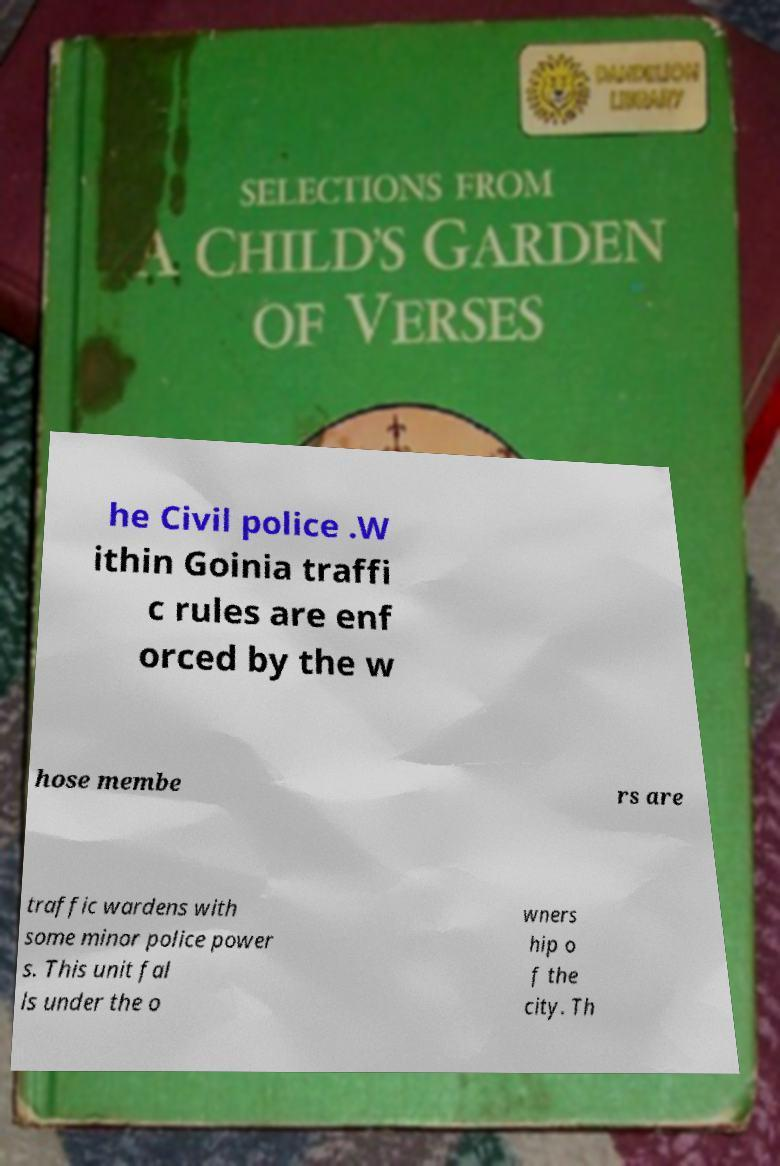Could you assist in decoding the text presented in this image and type it out clearly? he Civil police .W ithin Goinia traffi c rules are enf orced by the w hose membe rs are traffic wardens with some minor police power s. This unit fal ls under the o wners hip o f the city. Th 